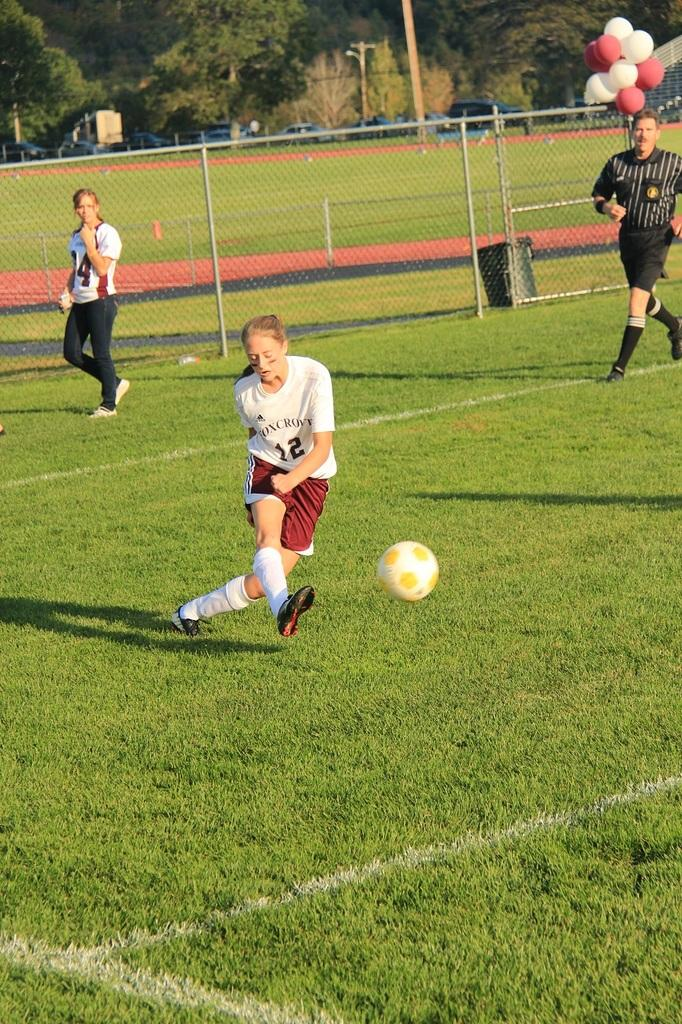<image>
Create a compact narrative representing the image presented. An athlete marked as number twelve is kicking at a ball. 